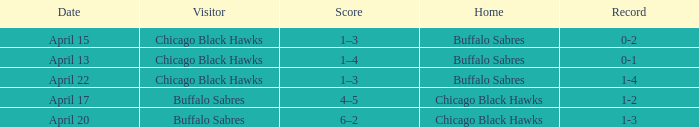Which Score has a Visitor of buffalo sabres and a Record of 1-3? 6–2. Could you parse the entire table? {'header': ['Date', 'Visitor', 'Score', 'Home', 'Record'], 'rows': [['April 15', 'Chicago Black Hawks', '1–3', 'Buffalo Sabres', '0-2'], ['April 13', 'Chicago Black Hawks', '1–4', 'Buffalo Sabres', '0-1'], ['April 22', 'Chicago Black Hawks', '1–3', 'Buffalo Sabres', '1-4'], ['April 17', 'Buffalo Sabres', '4–5', 'Chicago Black Hawks', '1-2'], ['April 20', 'Buffalo Sabres', '6–2', 'Chicago Black Hawks', '1-3']]} 